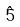Convert formula to latex. <formula><loc_0><loc_0><loc_500><loc_500>\hat { 5 }</formula> 